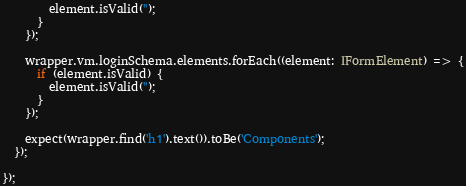Convert code to text. <code><loc_0><loc_0><loc_500><loc_500><_TypeScript_>        element.isValid('');
      }
    });

    wrapper.vm.loginSchema.elements.forEach((element: IFormElement) => {
      if (element.isValid) {
        element.isValid('');
      }
    });

    expect(wrapper.find('h1').text()).toBe('Components');
  });

});
</code> 